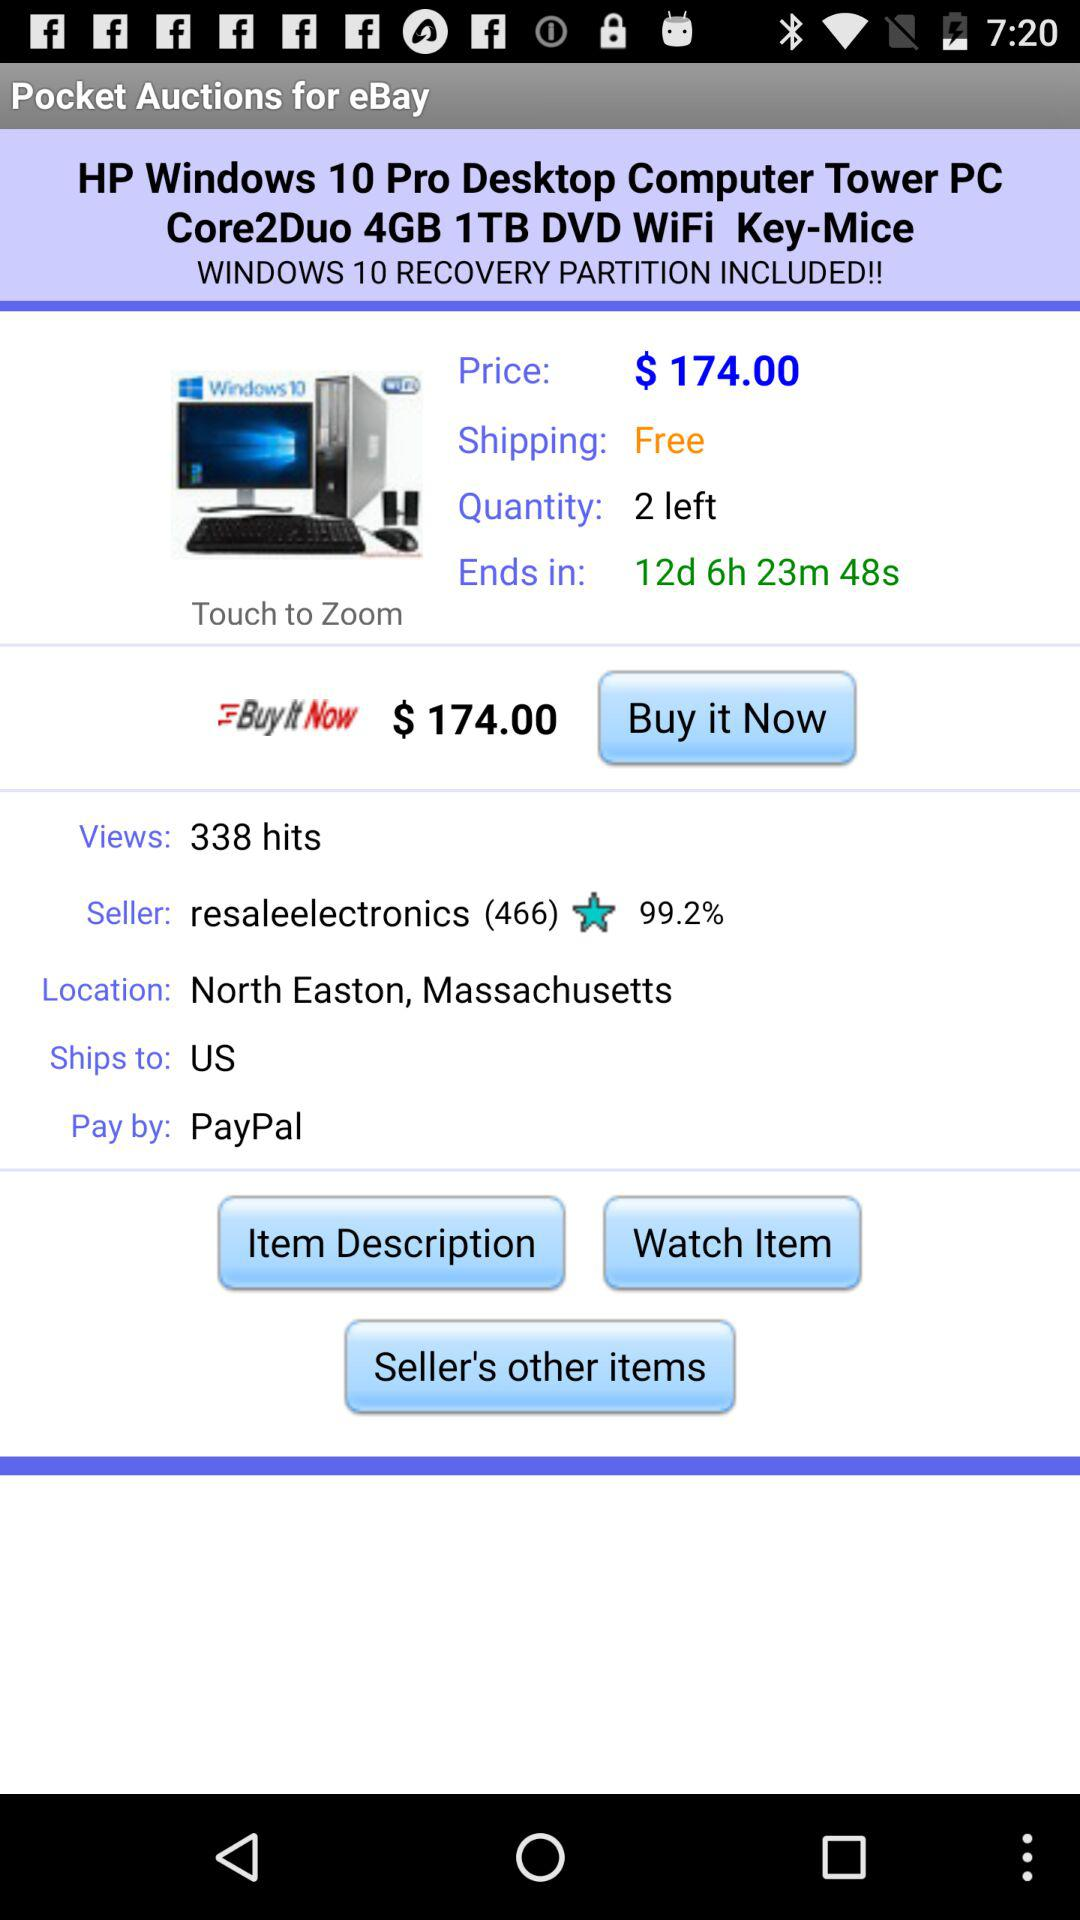What is the location? The location is North Easton, Massachusetts. 